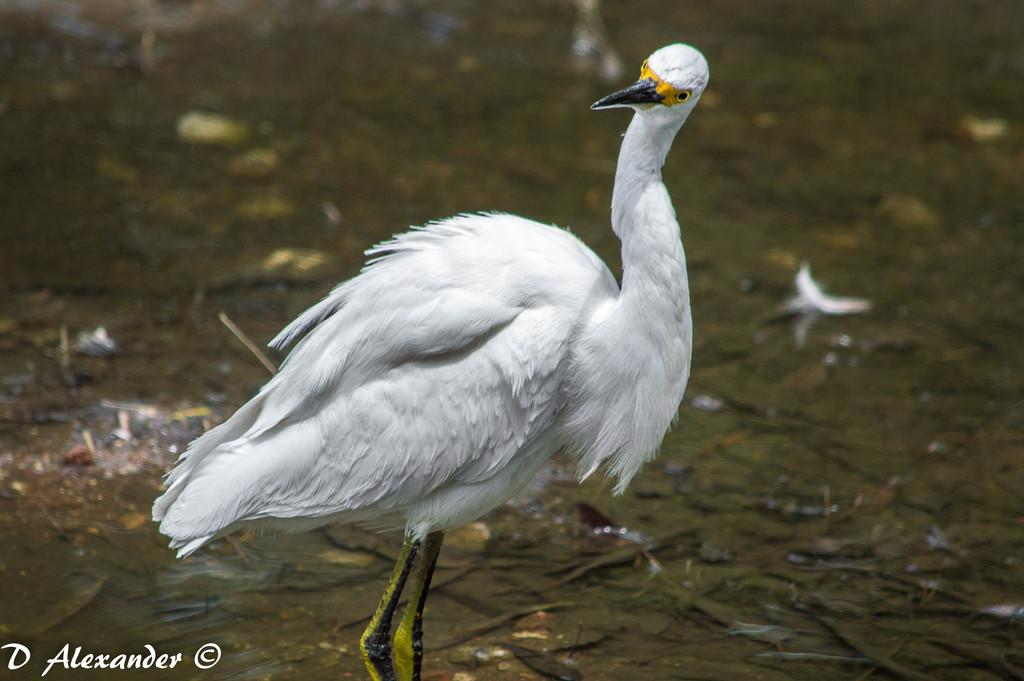What type of bird is in the picture? There is a crane bird in the picture. Is there any text or marking in the image? Yes, there is a watermark in the bottom left corner of the image. How many spots can be seen on the crane bird in the image? There are no spots visible on the crane bird in the image. Is there a man holding the crane bird in the image? No, there is no man present in the image. 